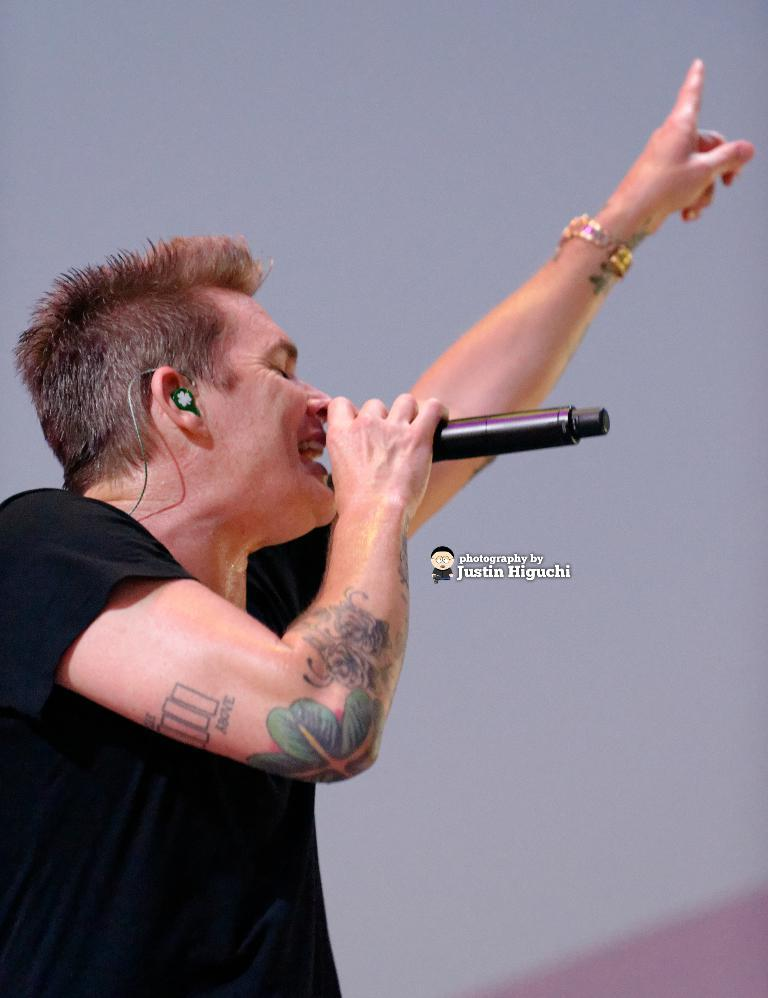What is the man in the image doing? The man is holding a mic and singing. What object is the man holding in the image? The man is holding a mic. What else can be seen in the image besides the man and the mic? There is a poster in the image. What type of peace symbol can be seen on the man's shirt in the image? There is no peace symbol or shirt mentioned in the provided facts, so it cannot be determined from the image. 